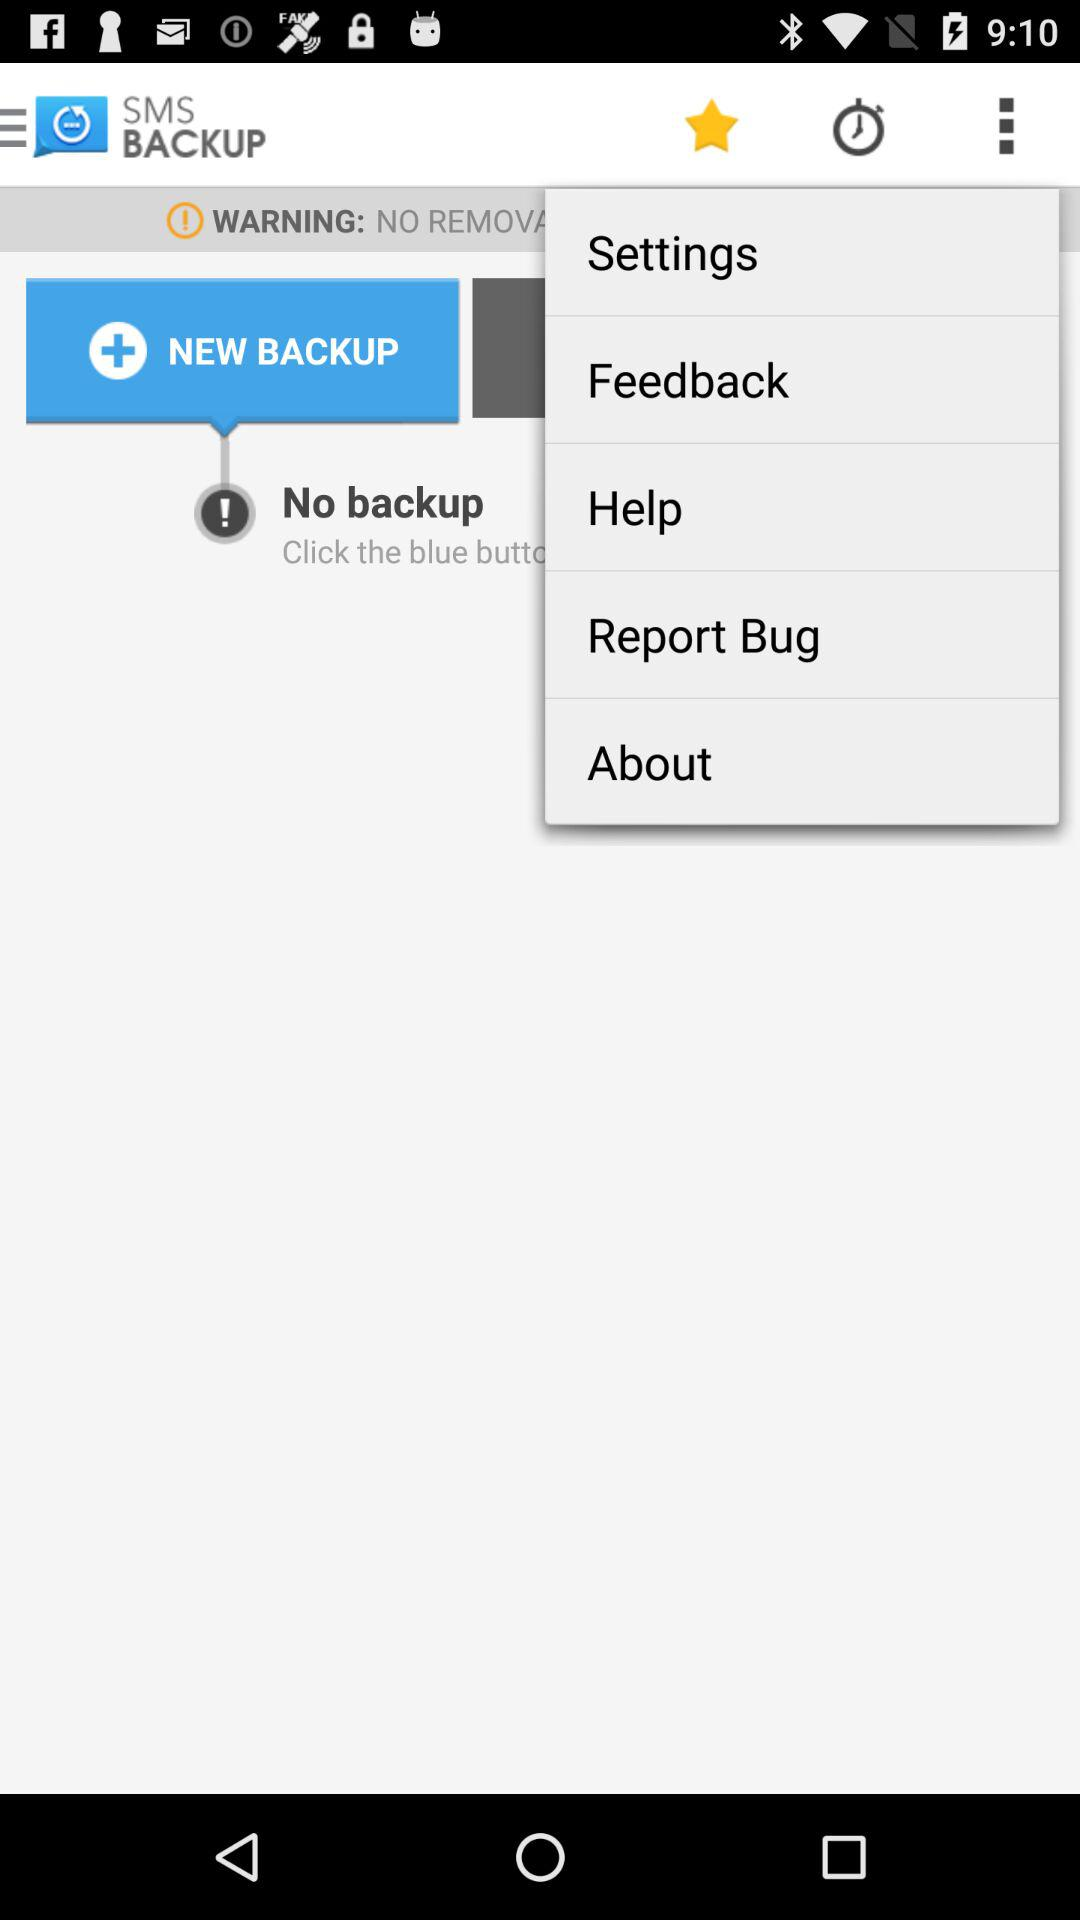What is the application name? The application name is "SMS BACKUP". 